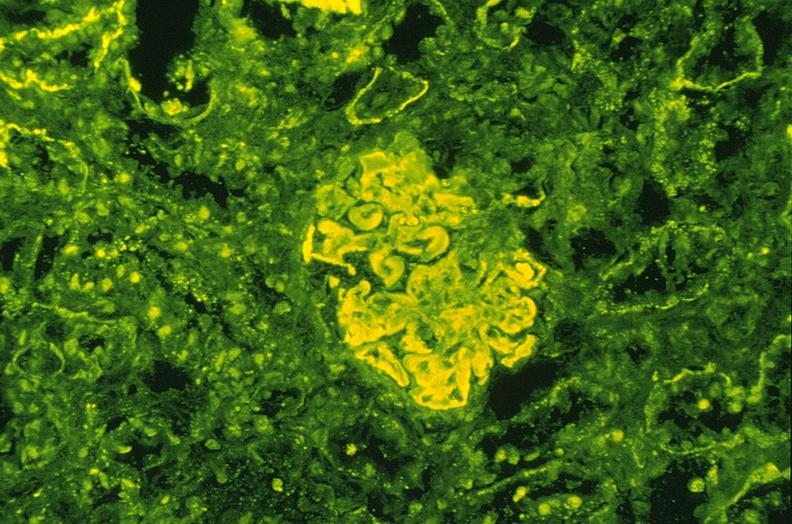what is present?
Answer the question using a single word or phrase. Urinary 